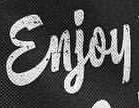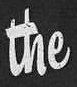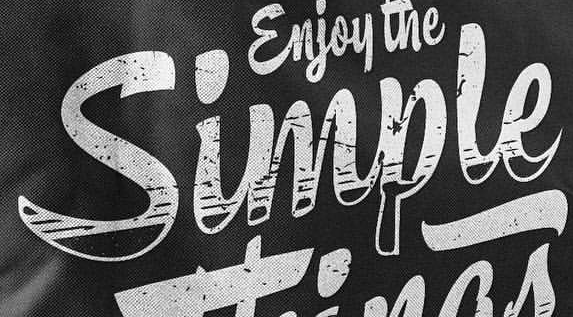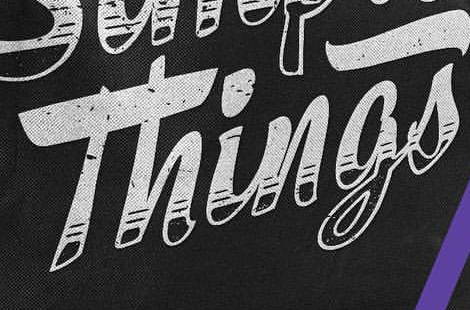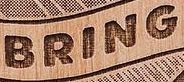What text is displayed in these images sequentially, separated by a semicolon? Enjoy; the; Simple; Things; BRING 